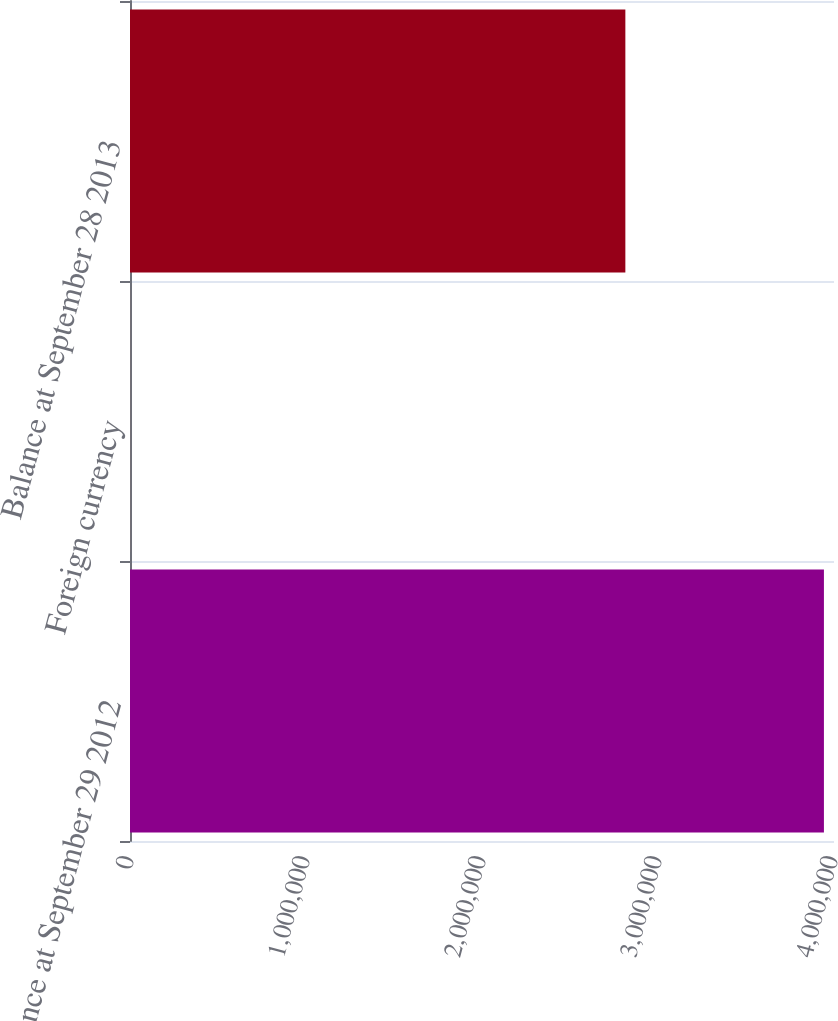Convert chart to OTSL. <chart><loc_0><loc_0><loc_500><loc_500><bar_chart><fcel>Balance at September 29 2012<fcel>Foreign currency<fcel>Balance at September 28 2013<nl><fcel>3.94278e+06<fcel>265<fcel>2.81453e+06<nl></chart> 